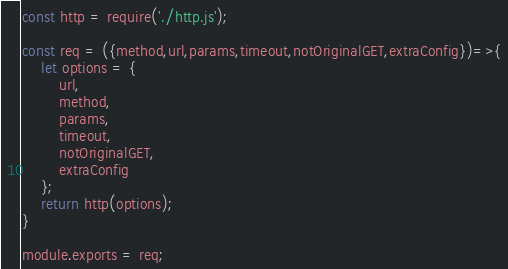Convert code to text. <code><loc_0><loc_0><loc_500><loc_500><_JavaScript_>const http = require('./http.js');

const req = ({method,url,params,timeout,notOriginalGET,extraConfig})=>{
    let options = {
        url,
        method,
        params,
        timeout,
        notOriginalGET,
        extraConfig
    };
    return http(options);
}

module.exports = req;</code> 